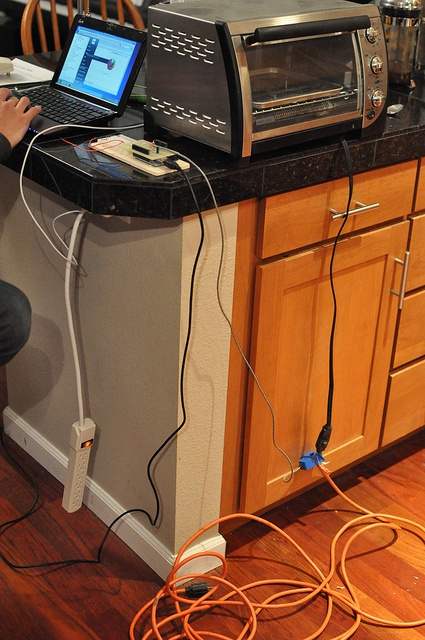Describe the objects in this image and their specific colors. I can see microwave in black and gray tones, laptop in black, lightblue, and gray tones, people in black, salmon, and gray tones, chair in black and gray tones, and chair in black, brown, and maroon tones in this image. 